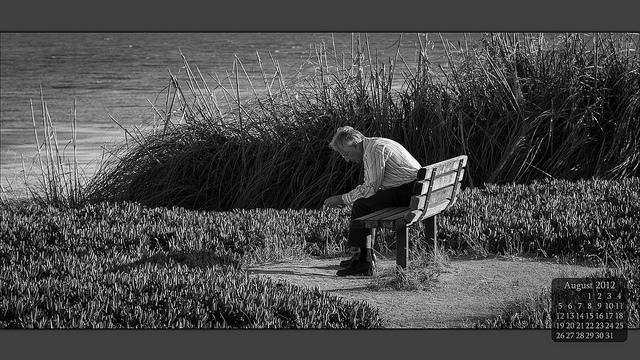Are both his feet on the ground?
Short answer required. Yes. Is this older man depressed?
Answer briefly. No. What is he sitting on?
Keep it brief. Bench. What is the man doing?
Keep it brief. Sitting. Is the man a sportsman?
Short answer required. No. Is this an elderly man?
Short answer required. Yes. 